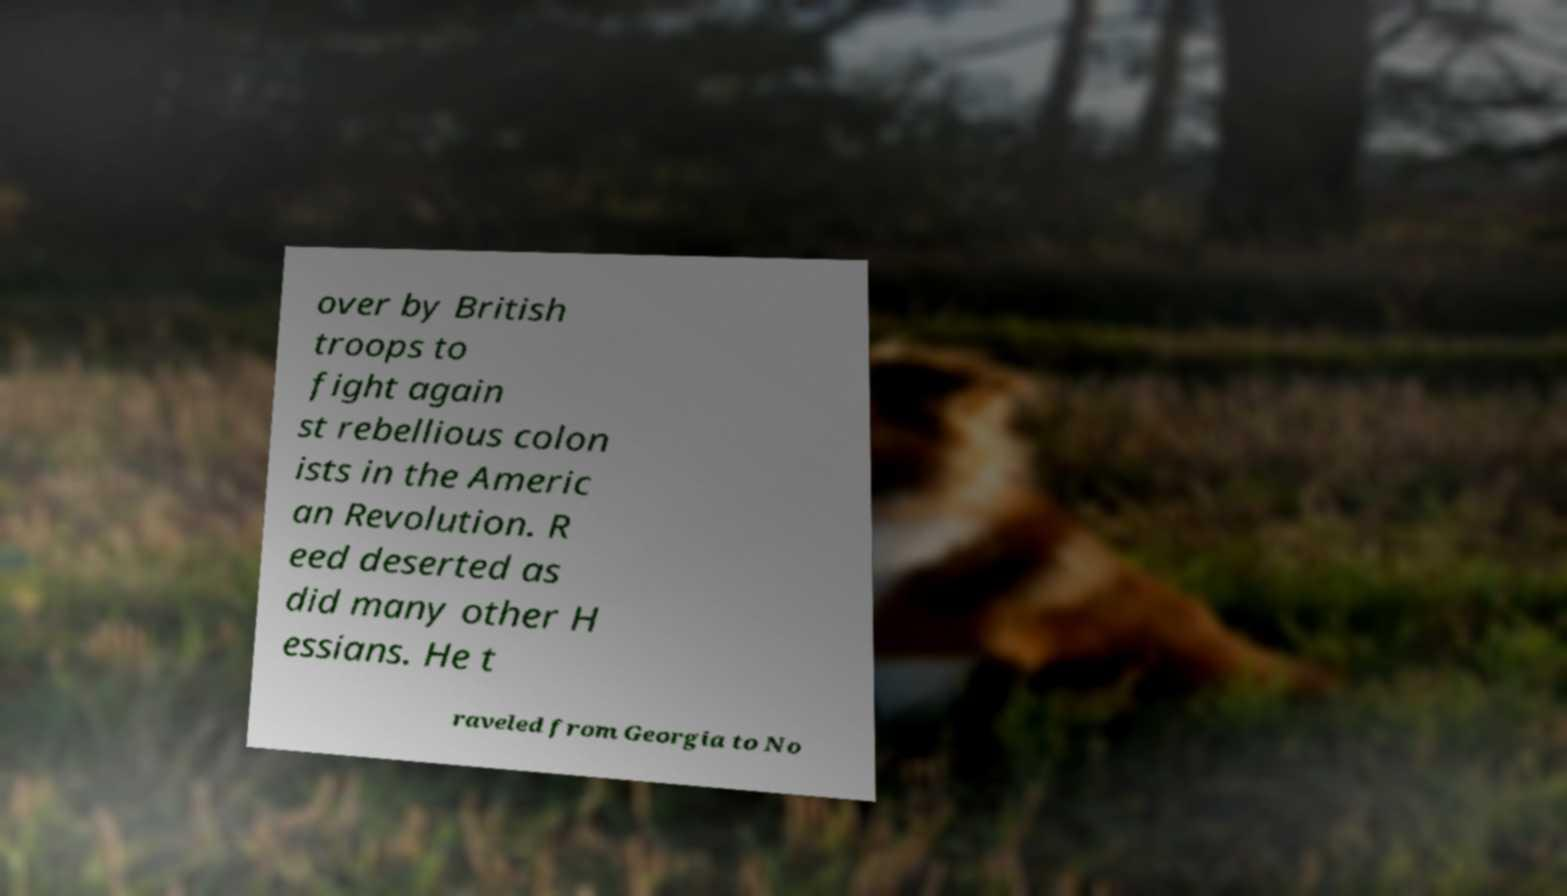I need the written content from this picture converted into text. Can you do that? over by British troops to fight again st rebellious colon ists in the Americ an Revolution. R eed deserted as did many other H essians. He t raveled from Georgia to No 